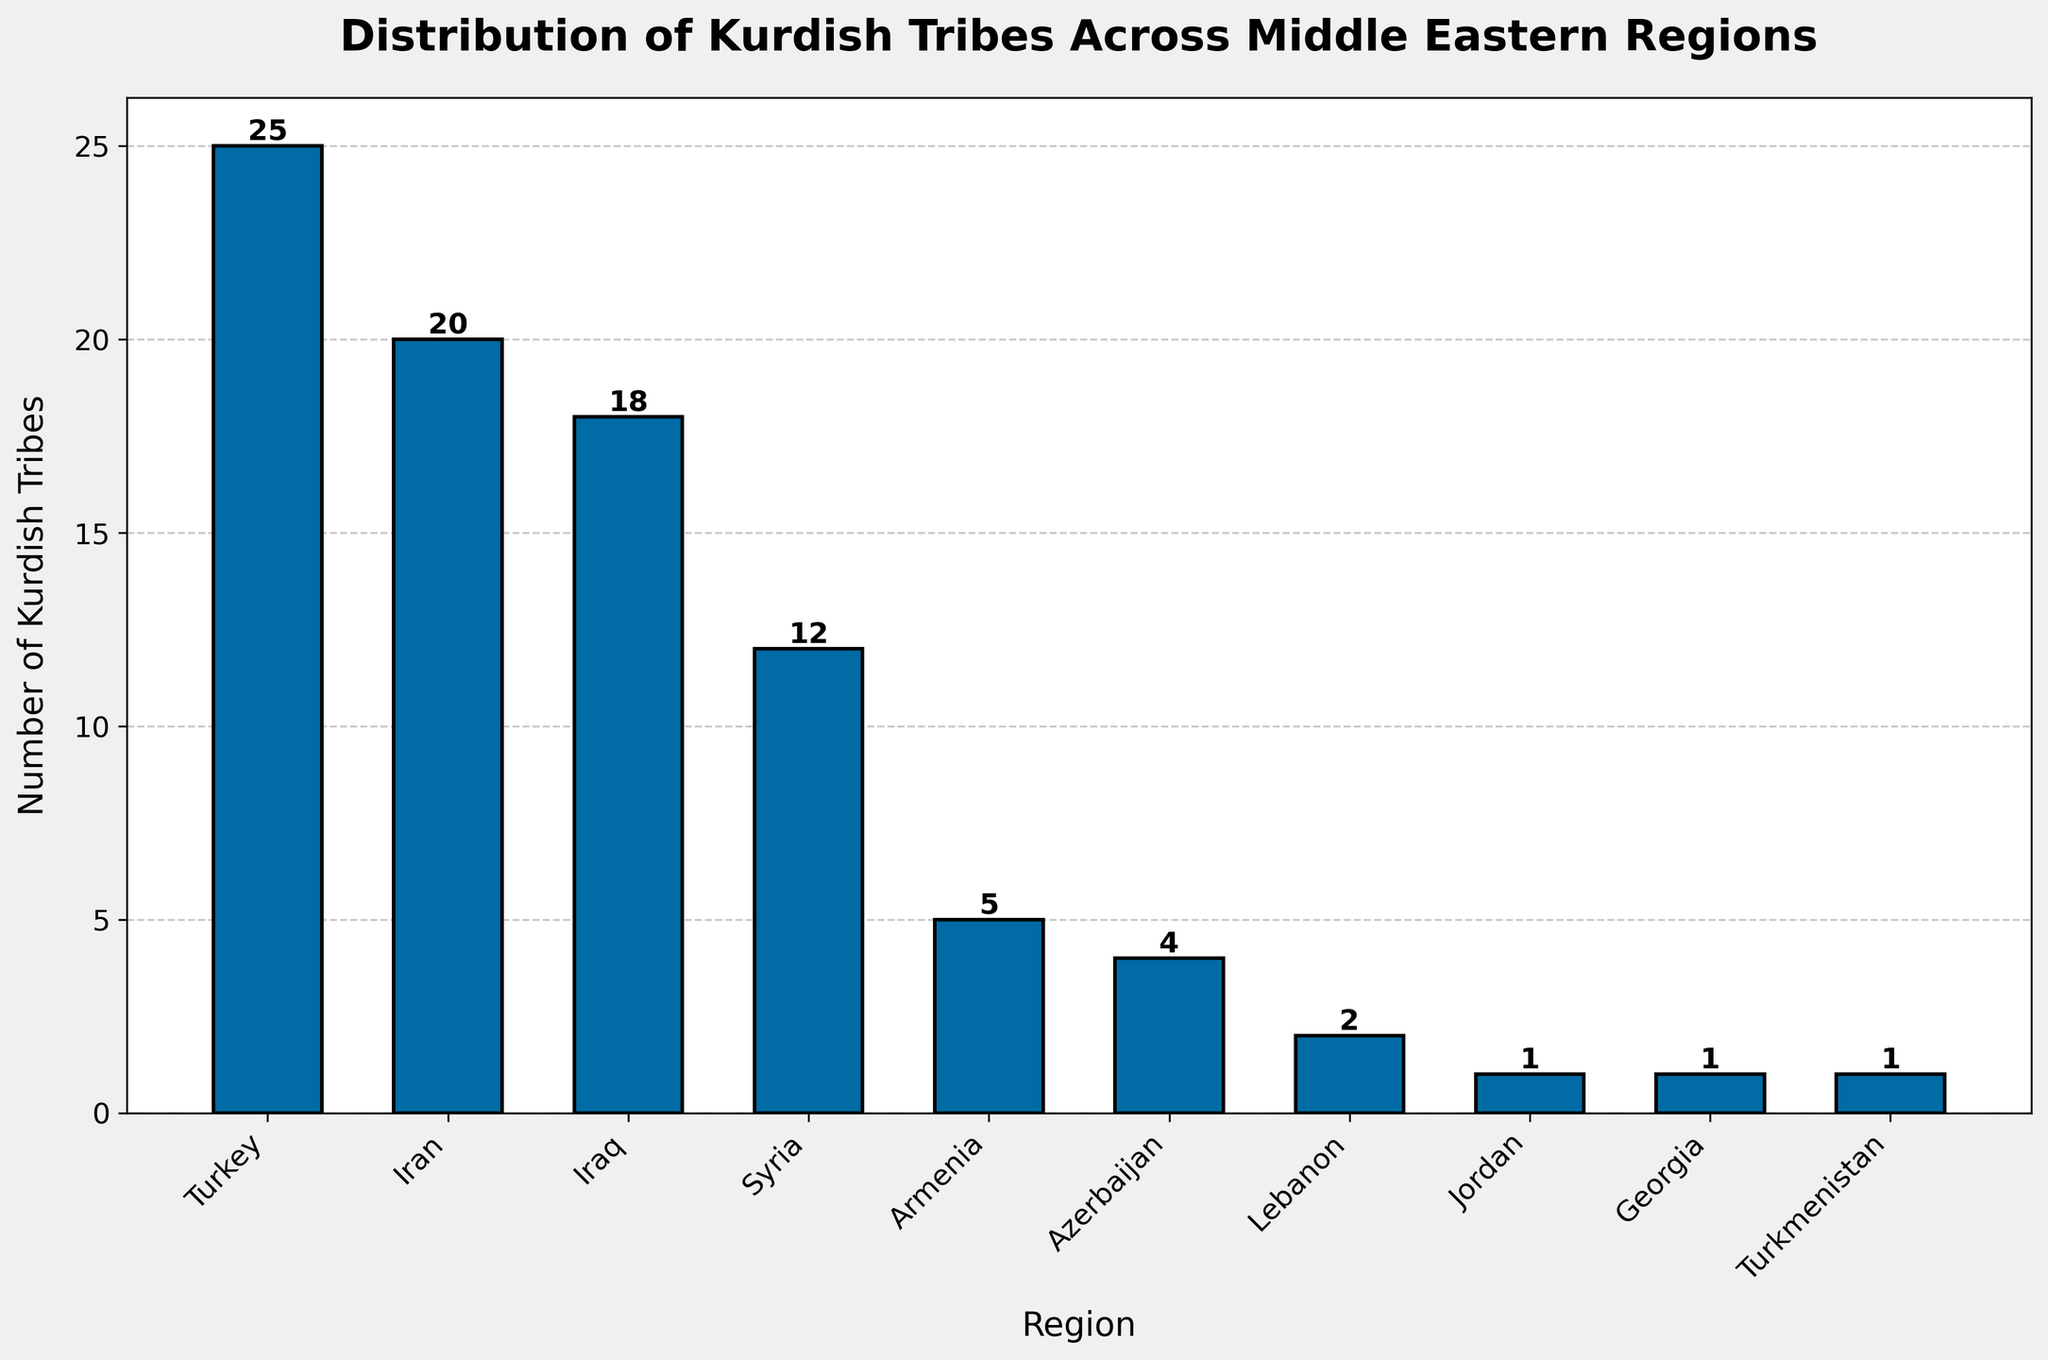what region has the highest number of Kurdish tribes? To find the region with the highest number of Kurdish tribes, look for the tallest bar in the chart, which corresponds to Turkey with 25 tribes.
Answer: Turkey how many more Kurdish tribes are there in Turkey than in Iran? Subtract the number of Kurdish tribes in Iran (20) from the number in Turkey (25). The difference is 25 - 20.
Answer: 5 which region has exactly one Kurdish tribe? Locate the bar with a height of 1 on the chart. There are three regions with exactly one Kurdish tribe: Jordan, Georgia, and Turkmenistan.
Answer: Jordan, Georgia, and Turkmenistan what is the total number of Kurdish tribes in the Middle East based on the chart? Sum the number of Kurdish tribes across all regions: 25 (Turkey) + 20 (Iran) + 18 (Iraq) + 12 (Syria) + 5 (Armenia) + 4 (Azerbaijan) + 2 (Lebanon) + 1 (Jordan) + 1 (Georgia) + 1 (Turkmenistan). Total is 89.
Answer: 89 how does the number of Kurdish tribes in Syria compare to Armenia and Azerbaijan combined? Add the number of Kurdish tribes in Armenia (5) and Azerbaijan (4), which equals 9, then compare this sum to the number in Syria (12). Syria has 3 more tribes than the combined total of Armenia and Azerbaijan.
Answer: Syria has 3 more tribes what are the regions with fewer Kurdish tribes than Iraq but more than Lebanon? Locate the bars representing Iraq (18 tribes) and Lebanon (2 tribes). Then find regions with tribe numbers between these values: Syria (12), Armenia (5), and Azerbaijan (4).
Answer: Syria, Armenia, and Azerbaijan which regions have fewer than 5 Kurdish tribes? Identify the regions with bars shorter than the height of the bar for 5 tribes. These are Azerbaijan (4), Lebanon (2), Jordan (1), Georgia (1), and Turkmenistan (1).
Answer: Azerbaijan, Lebanon, Jordan, Georgia, and Turkmenistan what is the average number of Kurdish tribes in Turkey, Iran, and Iraq? Add the number of Kurdish tribes in Turkey (25), Iran (20), and Iraq (18), then divide the sum by 3: (25 + 20 + 18) / 3 equals 63 / 3. The average is 21.
Answer: 21 how many regions have an equal or higher number of Kurdish tribes compared to Syria? Count the regions with bars of height 12 or more. These are Turkey (25), Iran (20), Iraq (18), and Syria (12). There are 4 regions.
Answer: 4 what is the difference in the number of Kurdish tribes between the region with the highest and the lowest numbers? Identify the highest number of Kurdish tribes in Turkey (25) and the lowest number in Jordan, Georgia, and Turkmenistan (each 1), then calculate the difference: 25 - 1.
Answer: 24 